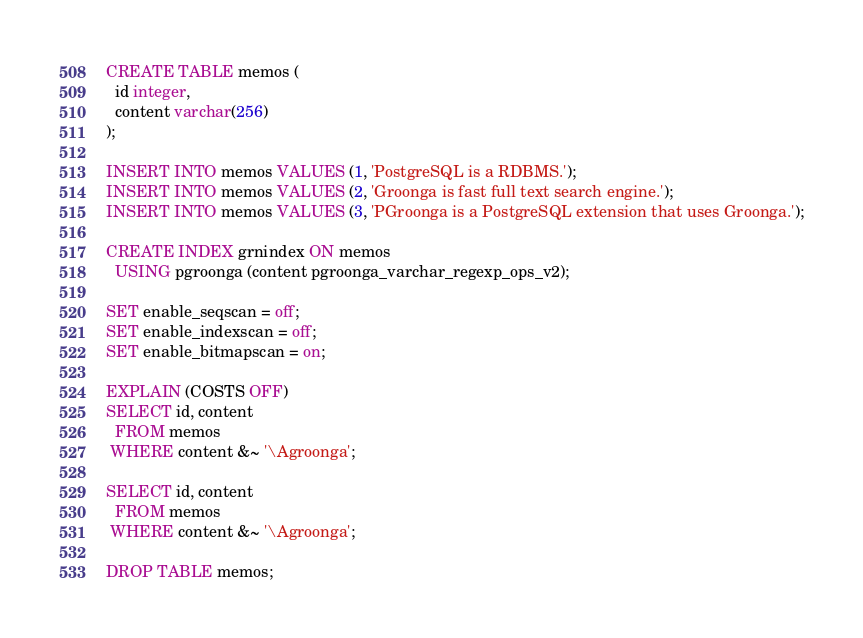<code> <loc_0><loc_0><loc_500><loc_500><_SQL_>CREATE TABLE memos (
  id integer,
  content varchar(256)
);

INSERT INTO memos VALUES (1, 'PostgreSQL is a RDBMS.');
INSERT INTO memos VALUES (2, 'Groonga is fast full text search engine.');
INSERT INTO memos VALUES (3, 'PGroonga is a PostgreSQL extension that uses Groonga.');

CREATE INDEX grnindex ON memos
  USING pgroonga (content pgroonga_varchar_regexp_ops_v2);

SET enable_seqscan = off;
SET enable_indexscan = off;
SET enable_bitmapscan = on;

EXPLAIN (COSTS OFF)
SELECT id, content
  FROM memos
 WHERE content &~ '\Agroonga';

SELECT id, content
  FROM memos
 WHERE content &~ '\Agroonga';

DROP TABLE memos;
</code> 